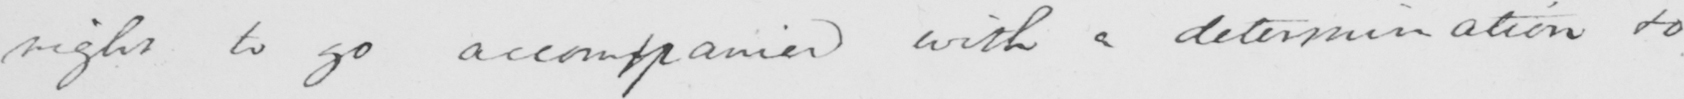Please provide the text content of this handwritten line. right to go accompanied with a determination to 